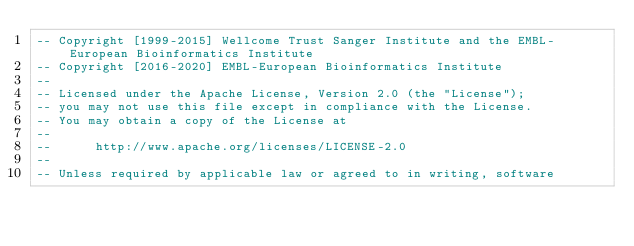Convert code to text. <code><loc_0><loc_0><loc_500><loc_500><_SQL_>-- Copyright [1999-2015] Wellcome Trust Sanger Institute and the EMBL-European Bioinformatics Institute
-- Copyright [2016-2020] EMBL-European Bioinformatics Institute
-- 
-- Licensed under the Apache License, Version 2.0 (the "License");
-- you may not use this file except in compliance with the License.
-- You may obtain a copy of the License at
-- 
--      http://www.apache.org/licenses/LICENSE-2.0
-- 
-- Unless required by applicable law or agreed to in writing, software</code> 